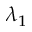<formula> <loc_0><loc_0><loc_500><loc_500>\lambda _ { 1 }</formula> 